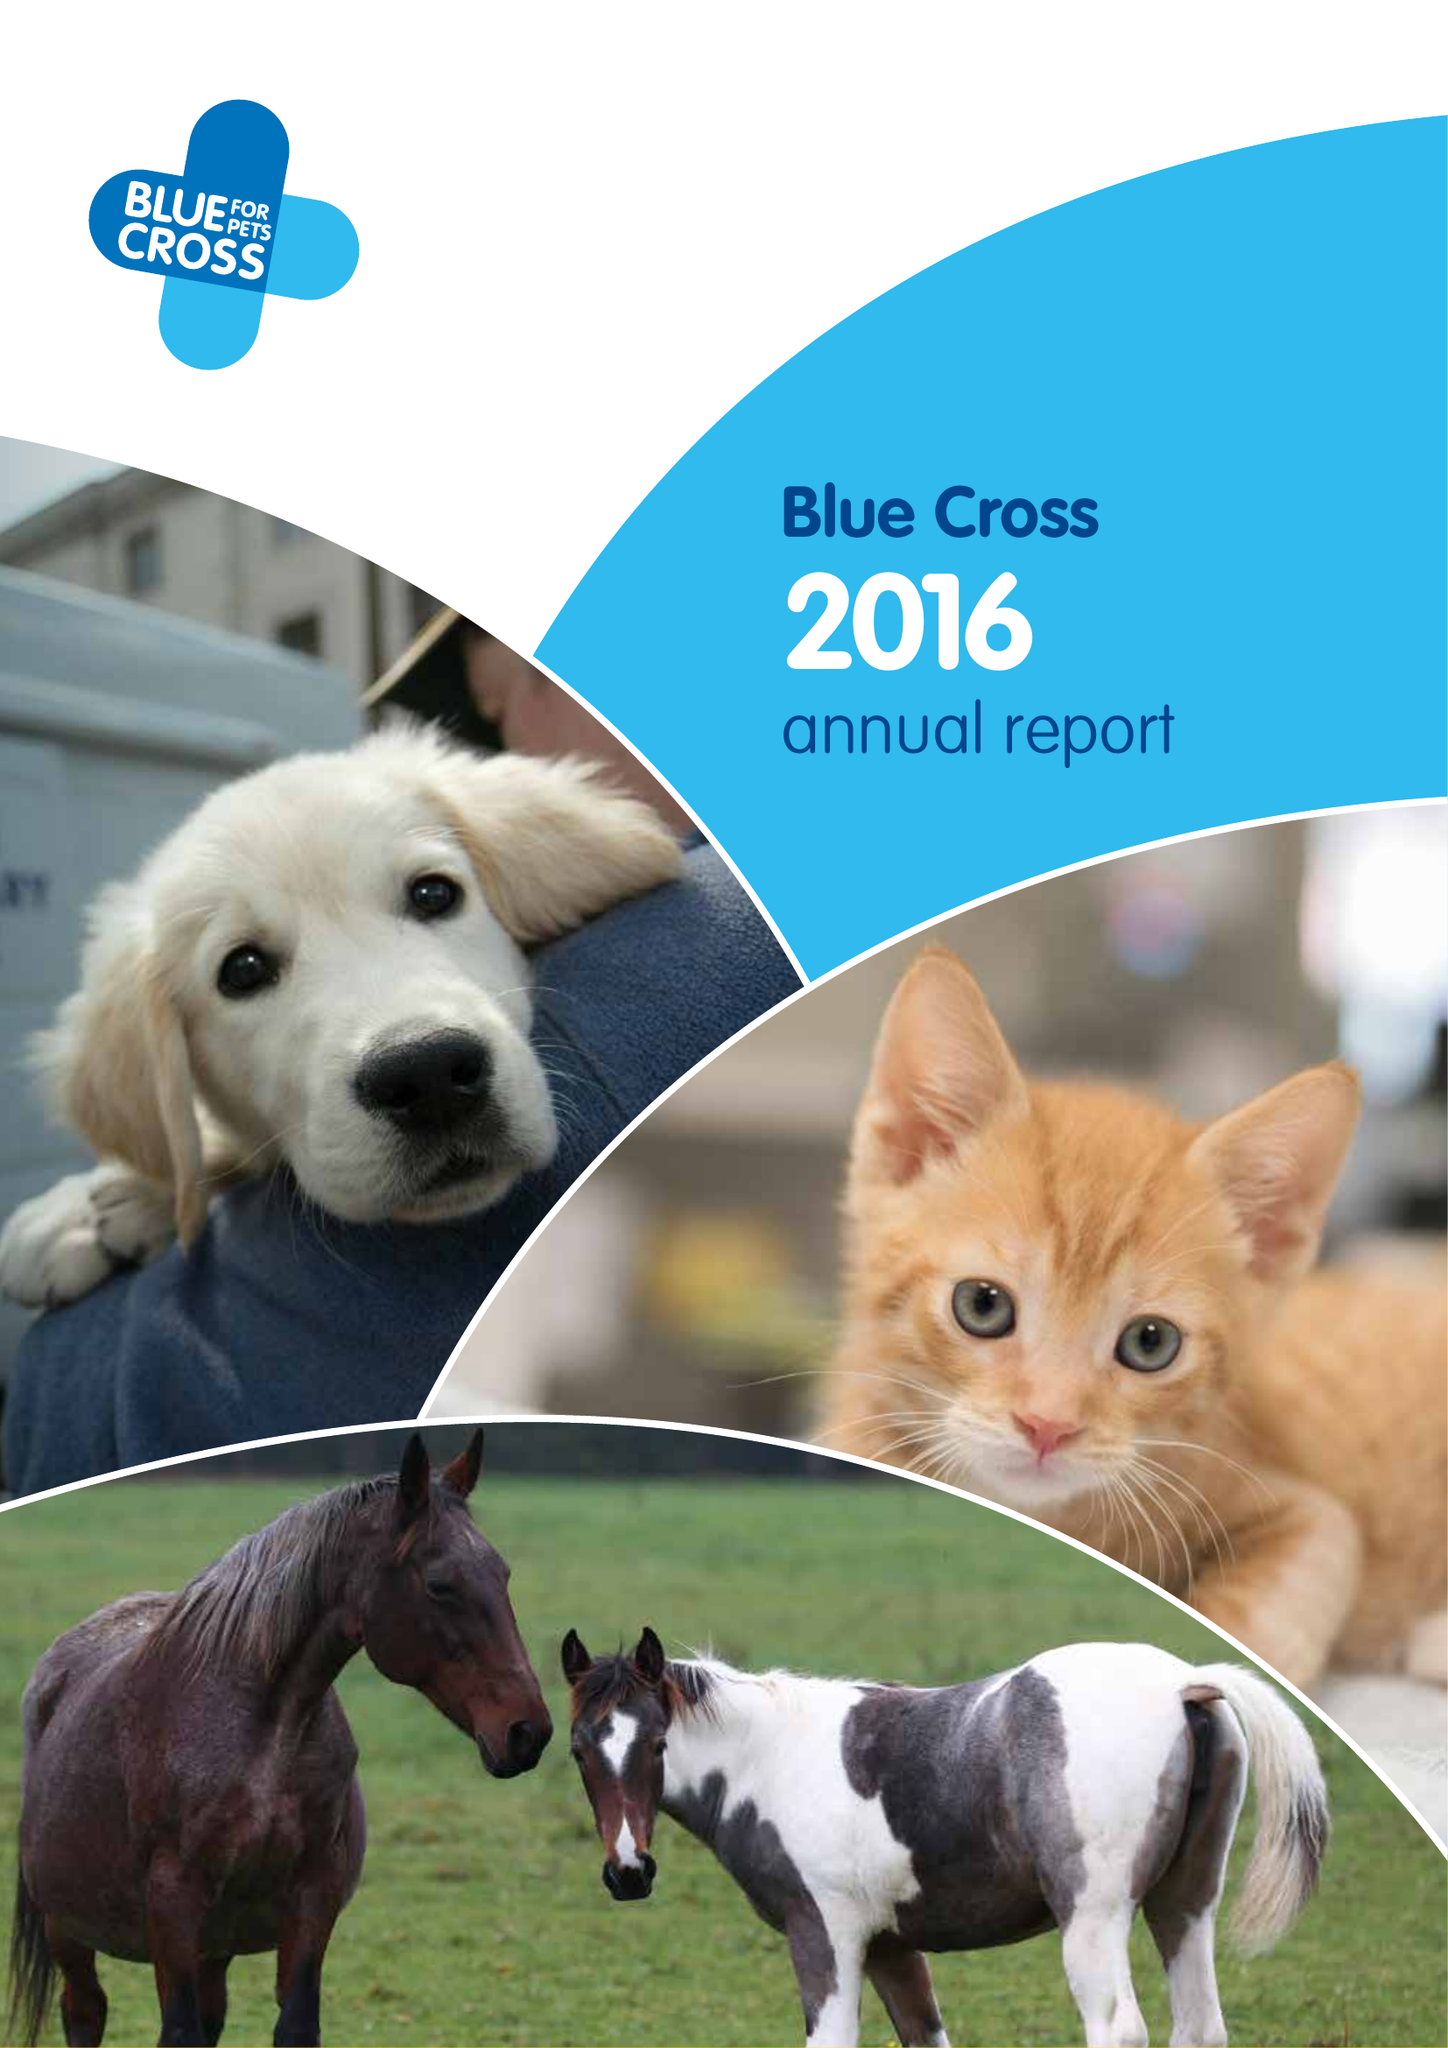What is the value for the income_annually_in_british_pounds?
Answer the question using a single word or phrase. 35294000.00 